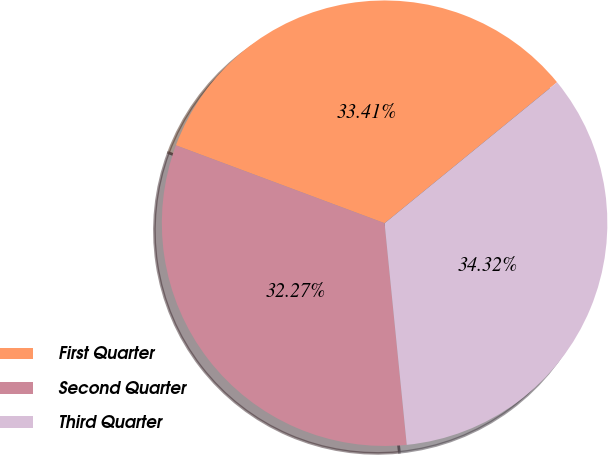<chart> <loc_0><loc_0><loc_500><loc_500><pie_chart><fcel>First Quarter<fcel>Second Quarter<fcel>Third Quarter<nl><fcel>33.41%<fcel>32.27%<fcel>34.32%<nl></chart> 